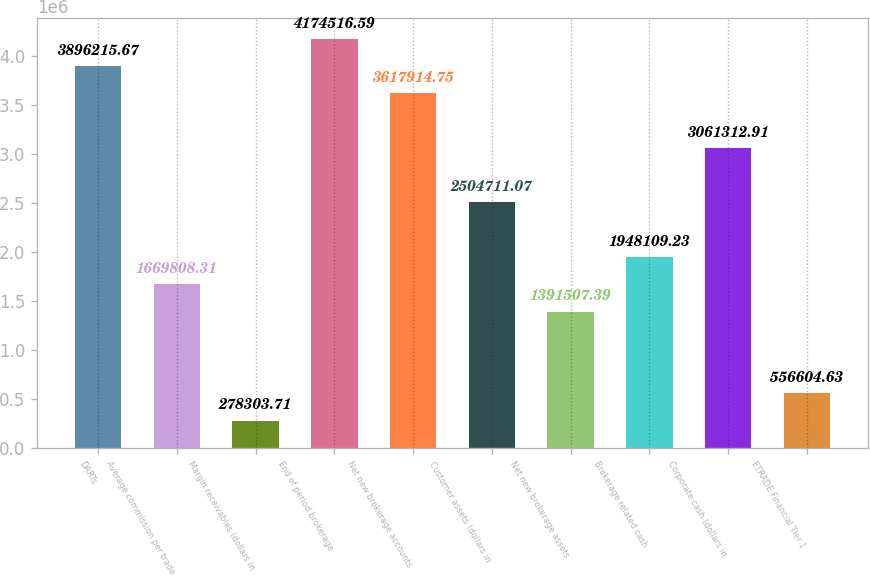<chart> <loc_0><loc_0><loc_500><loc_500><bar_chart><fcel>DARTs<fcel>Average commission per trade<fcel>Margin receivables (dollars in<fcel>End of period brokerage<fcel>Net new brokerage accounts<fcel>Customer assets (dollars in<fcel>Net new brokerage assets<fcel>Brokerage related cash<fcel>Corporate cash (dollars in<fcel>ETRADE Financial Tier 1<nl><fcel>3.89622e+06<fcel>1.66981e+06<fcel>278304<fcel>4.17452e+06<fcel>3.61791e+06<fcel>2.50471e+06<fcel>1.39151e+06<fcel>1.94811e+06<fcel>3.06131e+06<fcel>556605<nl></chart> 